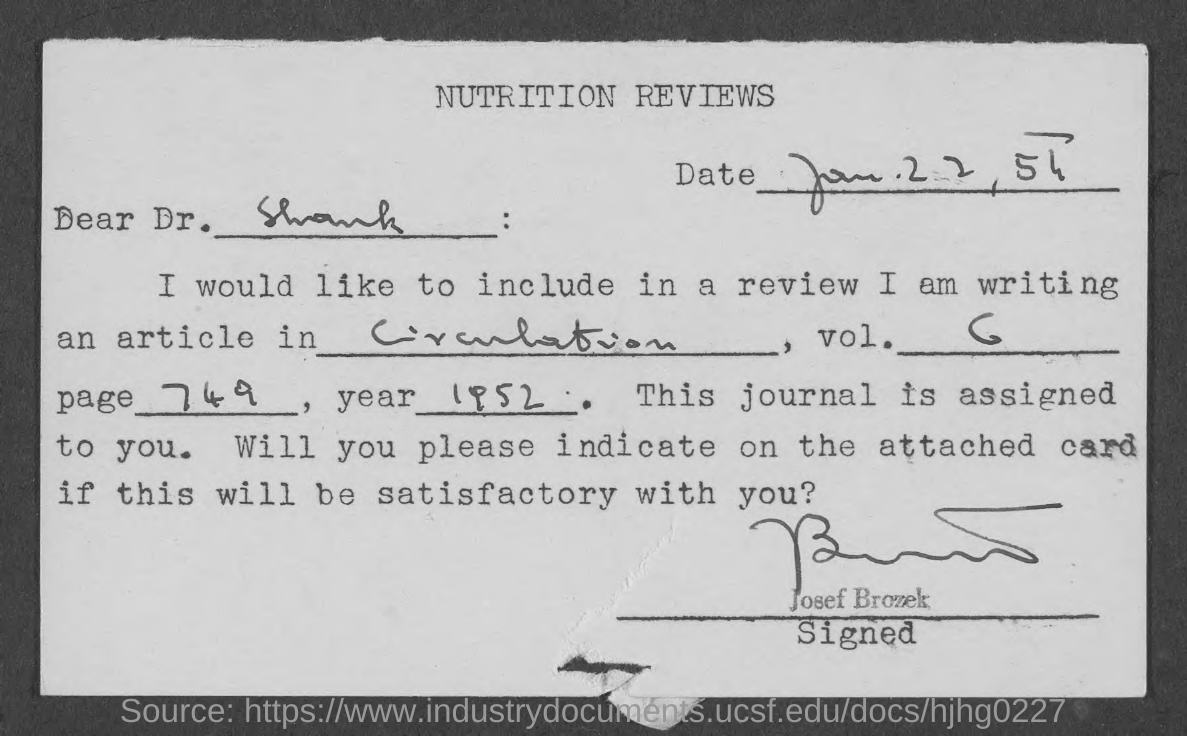To whom is the note addressed?
Offer a terse response. Dr. Shank. What is the document about?
Provide a short and direct response. Nutrition Reviews. Who has signed the document?
Offer a terse response. Josef Brozek. 